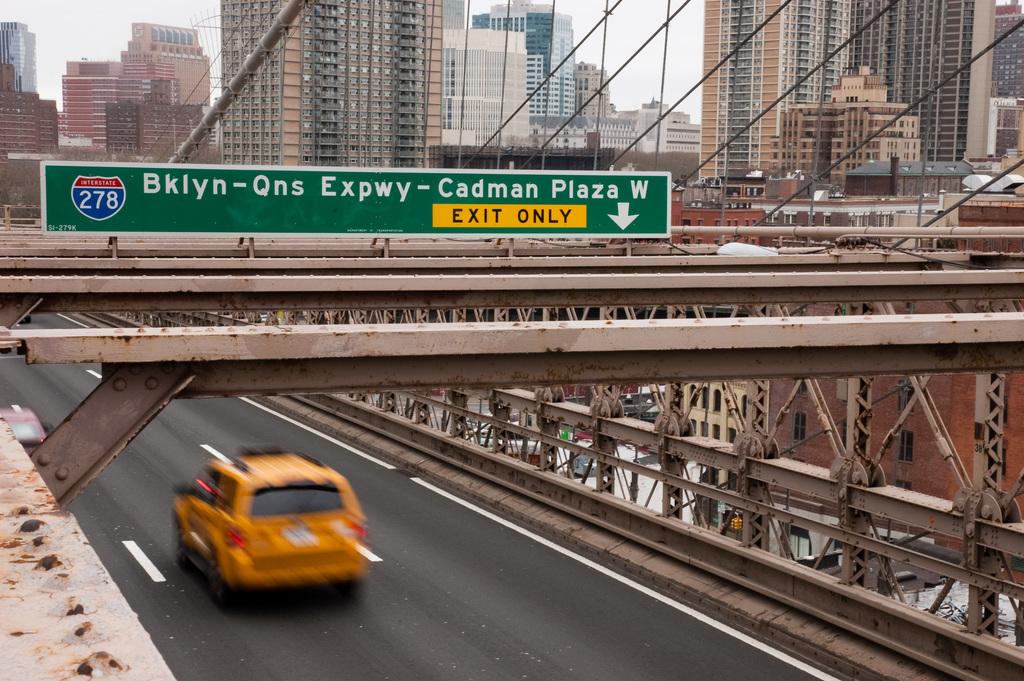What is the name of this upcoming exit?
Keep it short and to the point. Bklyn-qns expwy-cadman plaza w. What interstate is this road on?
Provide a short and direct response. 278. 